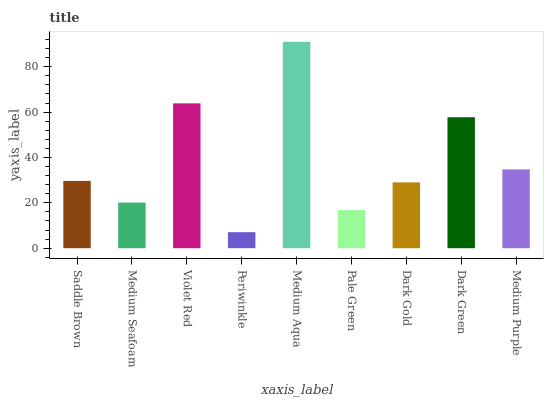Is Periwinkle the minimum?
Answer yes or no. Yes. Is Medium Aqua the maximum?
Answer yes or no. Yes. Is Medium Seafoam the minimum?
Answer yes or no. No. Is Medium Seafoam the maximum?
Answer yes or no. No. Is Saddle Brown greater than Medium Seafoam?
Answer yes or no. Yes. Is Medium Seafoam less than Saddle Brown?
Answer yes or no. Yes. Is Medium Seafoam greater than Saddle Brown?
Answer yes or no. No. Is Saddle Brown less than Medium Seafoam?
Answer yes or no. No. Is Saddle Brown the high median?
Answer yes or no. Yes. Is Saddle Brown the low median?
Answer yes or no. Yes. Is Periwinkle the high median?
Answer yes or no. No. Is Medium Purple the low median?
Answer yes or no. No. 